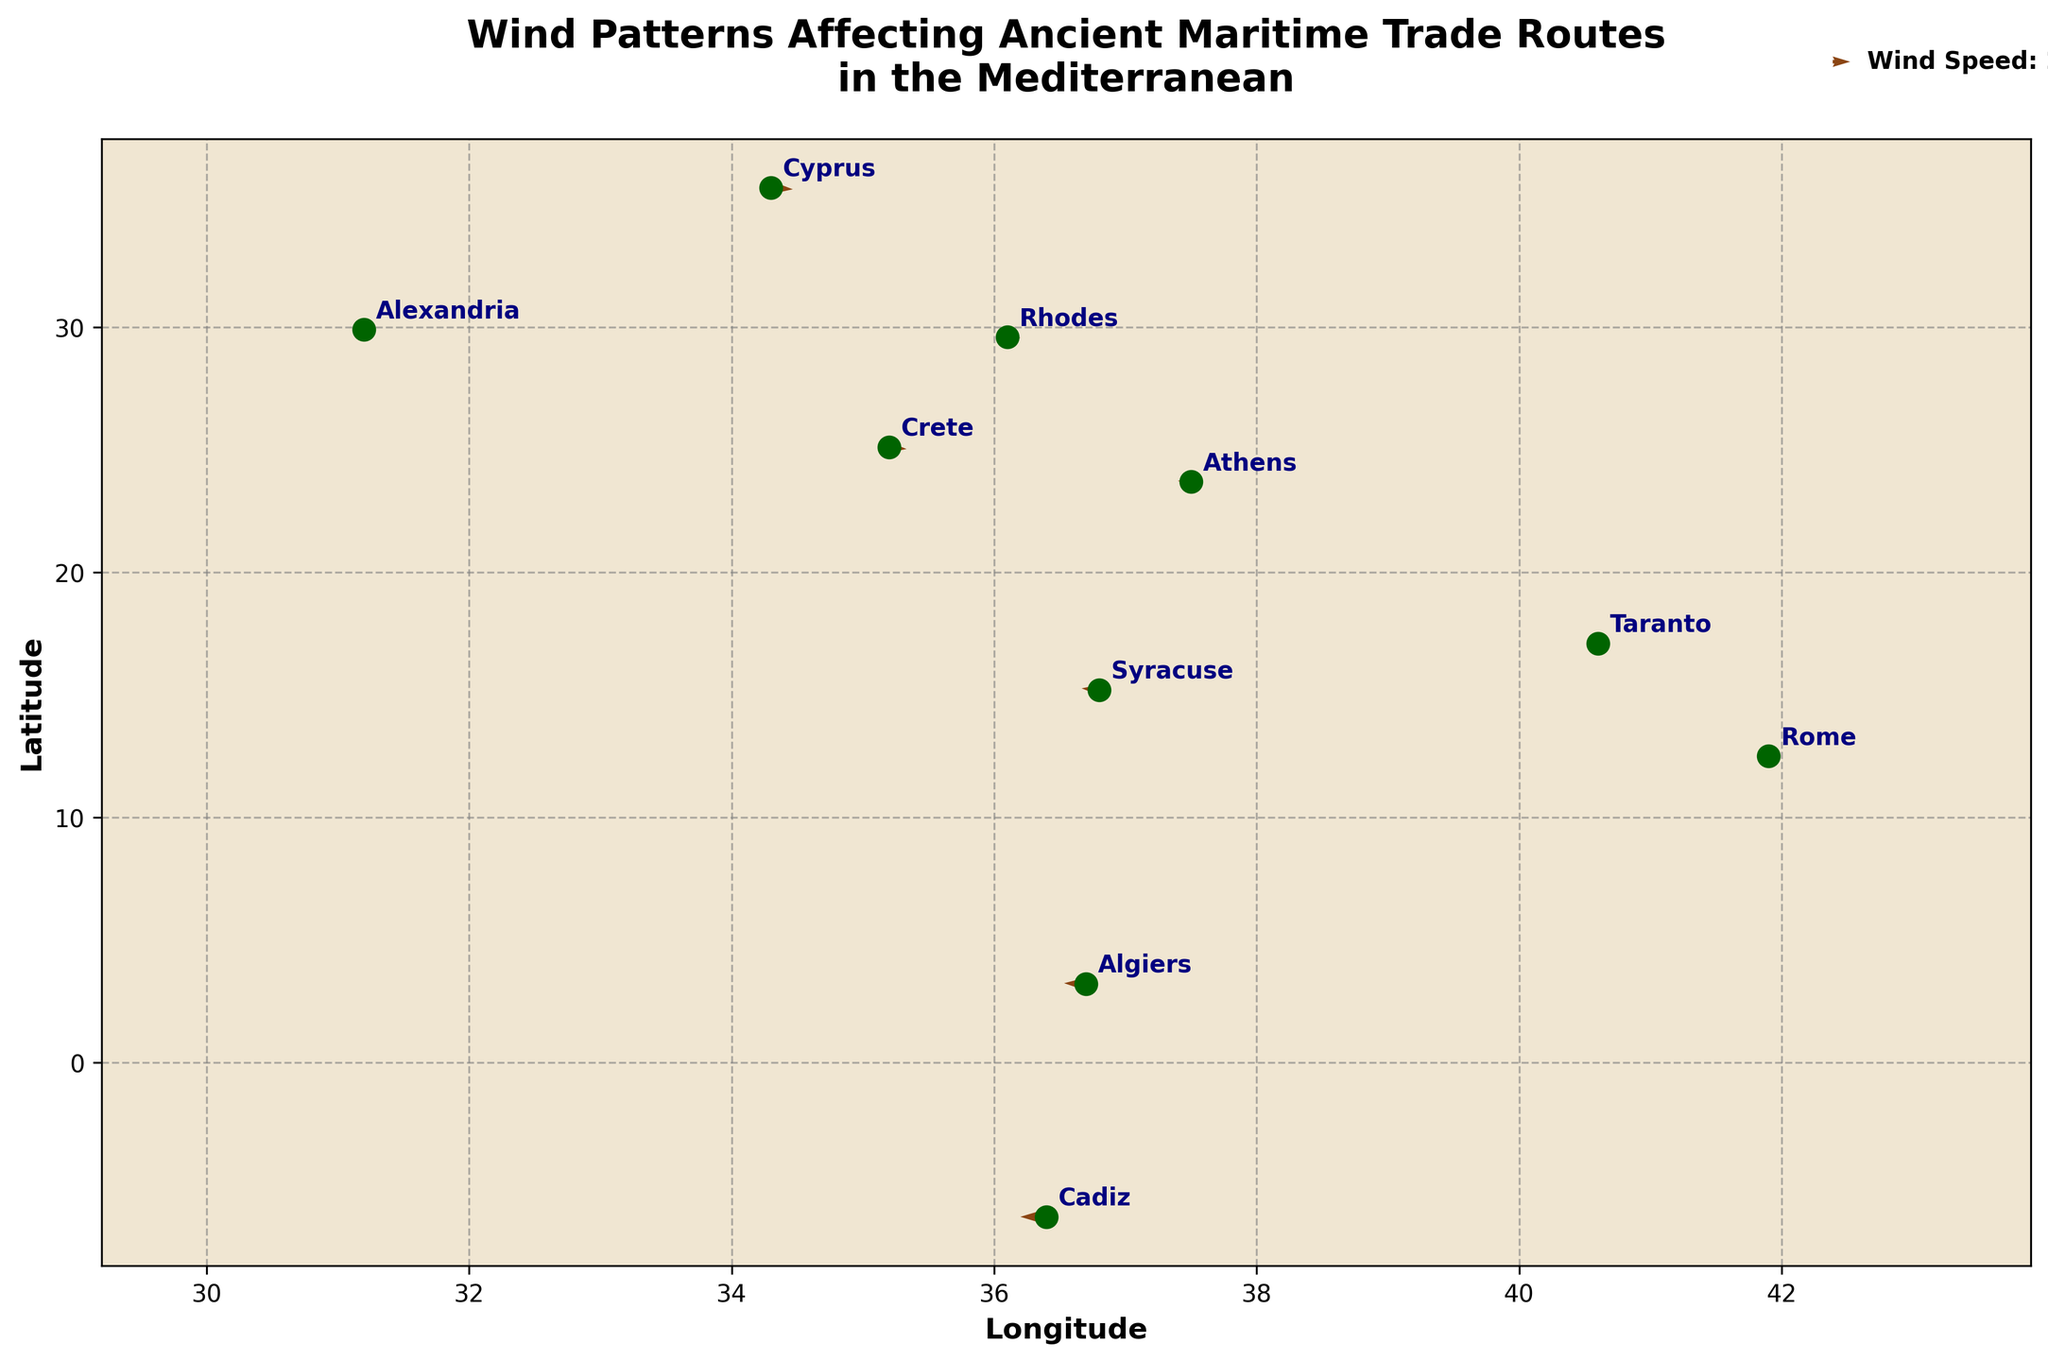What's the title of the figure? The title of a figure is typically placed at the top and is usually in a larger or bold font to stand out. Here, it's located at the top.
Answer: Wind Patterns Affecting Ancient Maritime Trade Routes in the Mediterranean How many locations are plotted in the figure? Count the number of unique location labels provided in the dataset and displayed on the plot.
Answer: 10 Which direction is the wind blowing in Rhodes? Look at the direction of the arrow originating from the point representing Rhodes on the plot (Rhodes is located at coordinates (36.1, 29.6)). The arrow indicates wind direction and speed.
Answer: Mainly to the southeast What is the wind speed and direction in Cadiz? The wind speed is determined by the length and scale of the arrows in the plot, while the direction is indicated by the arrow's direction. The wind arrow at Cadiz (coordinates (36.4, -6.3)) is horizontally directed to the left (west) with no vertical component.
Answer: Speed: 3 units, Direction: west Compare the wind patterns in Rome and Athens. Which city experiences stronger winds? Compare the arrow lengths for Rome (41.9, 12.5) and Athens (37.5, 23.7). The longer the arrow, the stronger the wind. Rome has a longer arrow with components (-1, 2) compared to Athens' arrow of (-1.5, 0.5) when adjusted for the same scale.
Answer: Rome Where is the wind blowing strongest in the Mediterranean according to the plot? Identify the location with the longest arrow, indicating the highest wind speed. Check the length and corresponding scale in the legend.
Answer: Cadiz Which location experiences northward winds? Look for arrows pointing upwards, generally indicating a wind blowing from the south to the north. One such location based on the quiver data is Rome, with an arrow component pointing upward.
Answer: Rome Calculate the combined east-west wind component (u) for the entire dataset. Sum all the u components from the data. The values are: -2, -1.5, -1, 1.5, 2, 1, -2.5, -1, -3, and 2. Adding these gives: -2 + (-1.5) + (-1) + 1.5 + 2 + 1 + (-2.5) + (-1) + (-3) + 2.
Answer: -4.5 Which city shows the greatest variation in wind direction? Analyze the quiver arrows for directional changes across the figure. Athens (with components -1.5, 0.5) and Taranto (with components -1, -1.5) have significant directional differences.
Answer: Rome Who might have faced the most challenging maritime navigation based on the wind patterns? Consider the wind speed and direction, evaluation of the regions with the strongest and most unpredictable wind patterns. Cadiz, facing the strongest winds blowing directly from the west, would likely provide challenges for navigation.
Answer: Cadiz 